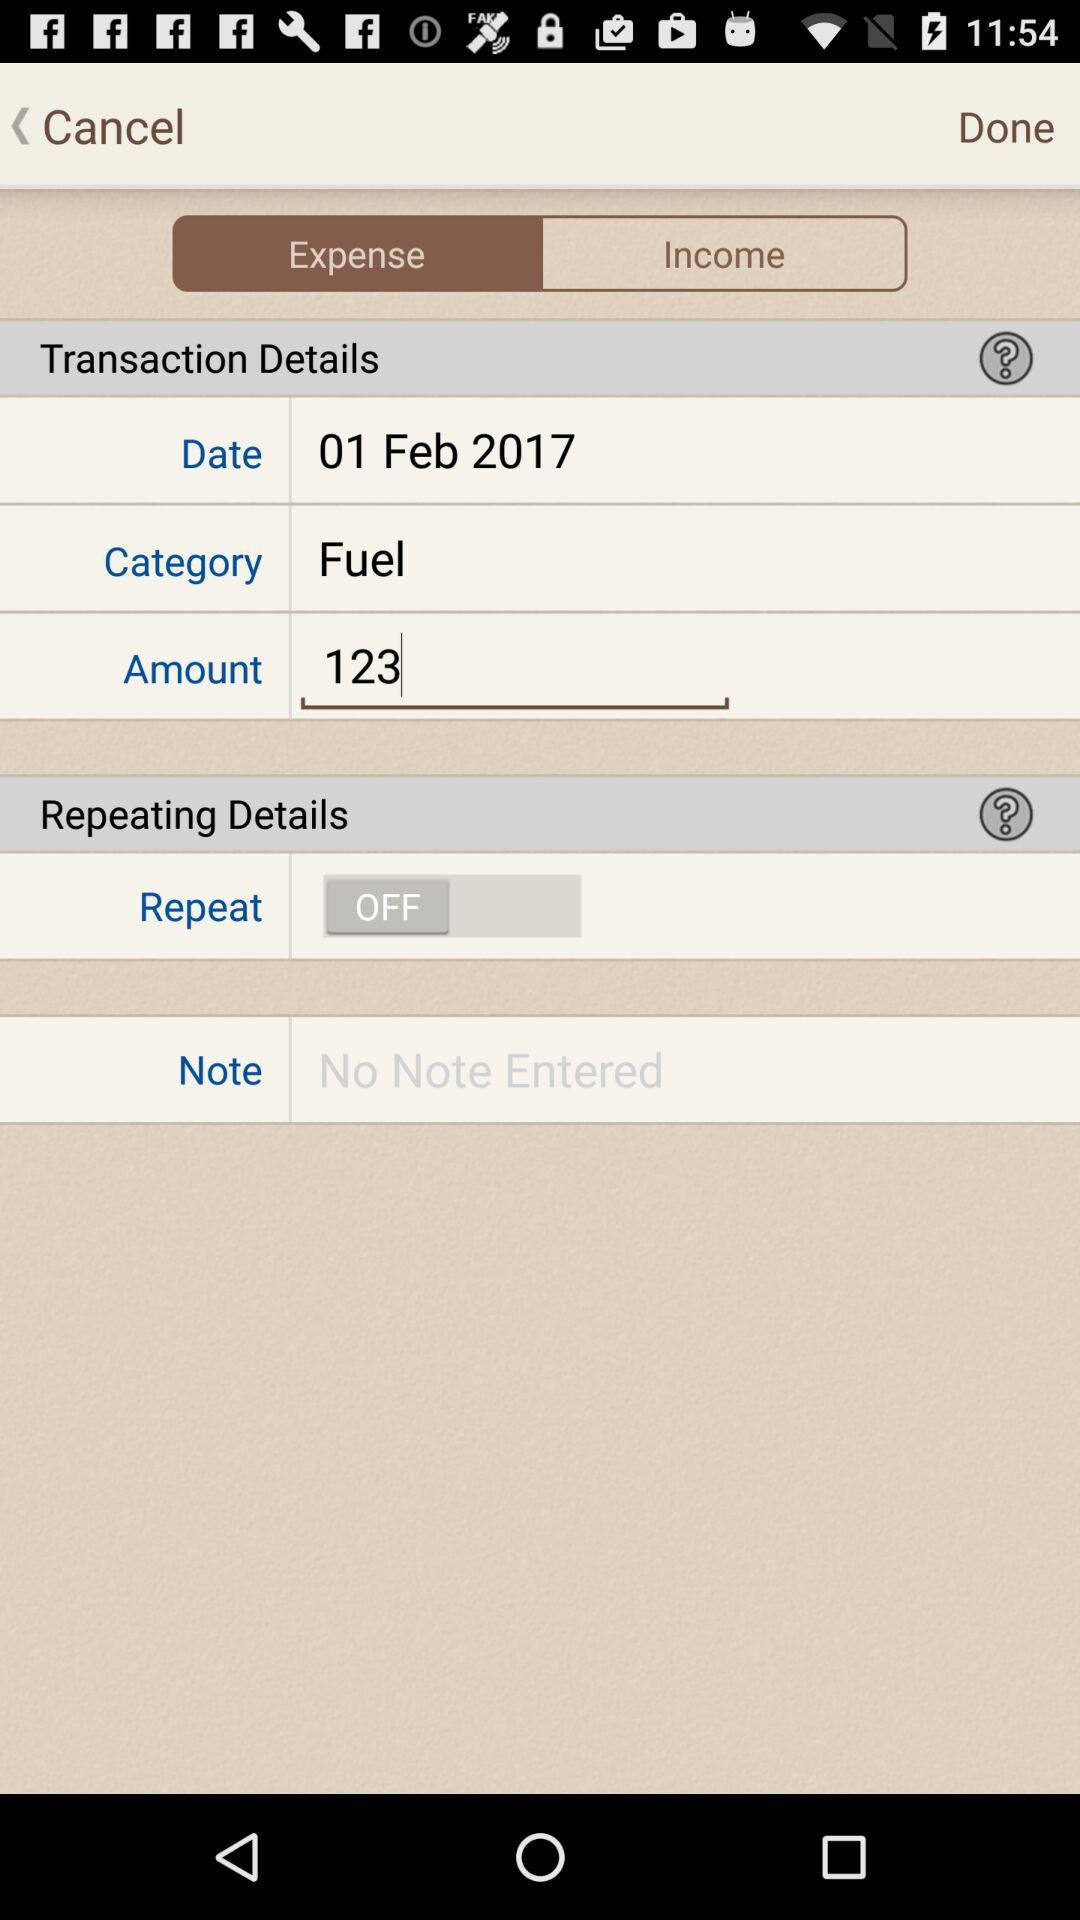What is the category of the transaction?
Answer the question using a single word or phrase. Fuel 